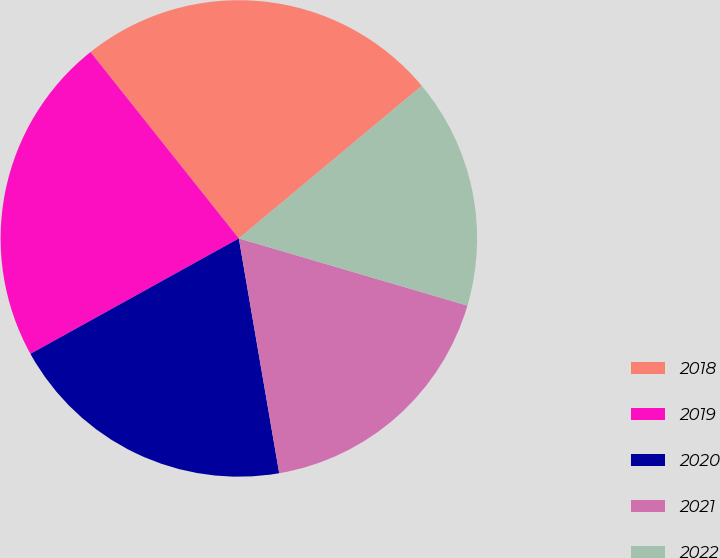<chart> <loc_0><loc_0><loc_500><loc_500><pie_chart><fcel>2018<fcel>2019<fcel>2020<fcel>2021<fcel>2022<nl><fcel>24.63%<fcel>22.35%<fcel>19.66%<fcel>17.74%<fcel>15.61%<nl></chart> 